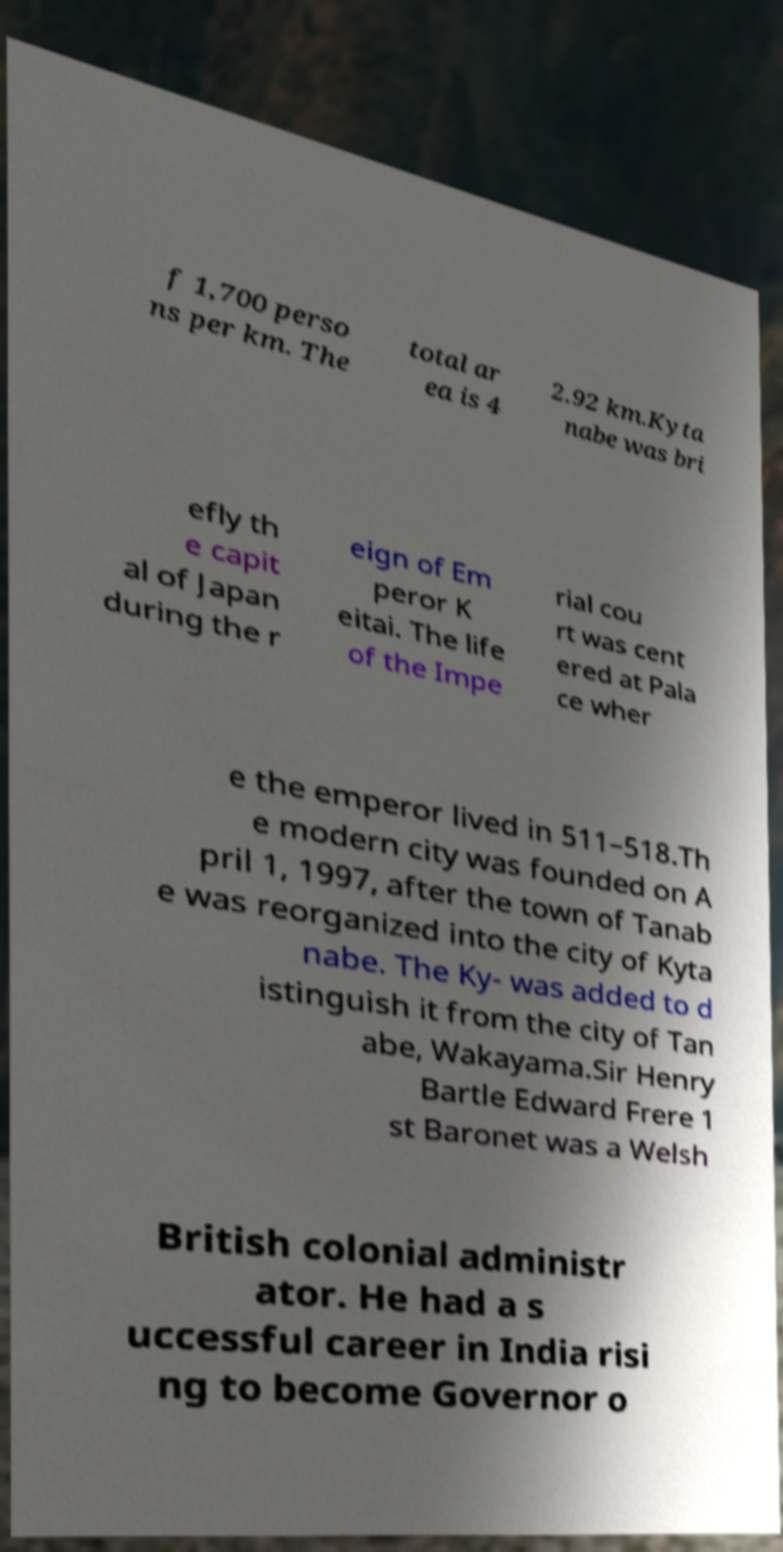I need the written content from this picture converted into text. Can you do that? f 1,700 perso ns per km. The total ar ea is 4 2.92 km.Kyta nabe was bri efly th e capit al of Japan during the r eign of Em peror K eitai. The life of the Impe rial cou rt was cent ered at Pala ce wher e the emperor lived in 511–518.Th e modern city was founded on A pril 1, 1997, after the town of Tanab e was reorganized into the city of Kyta nabe. The Ky- was added to d istinguish it from the city of Tan abe, Wakayama.Sir Henry Bartle Edward Frere 1 st Baronet was a Welsh British colonial administr ator. He had a s uccessful career in India risi ng to become Governor o 